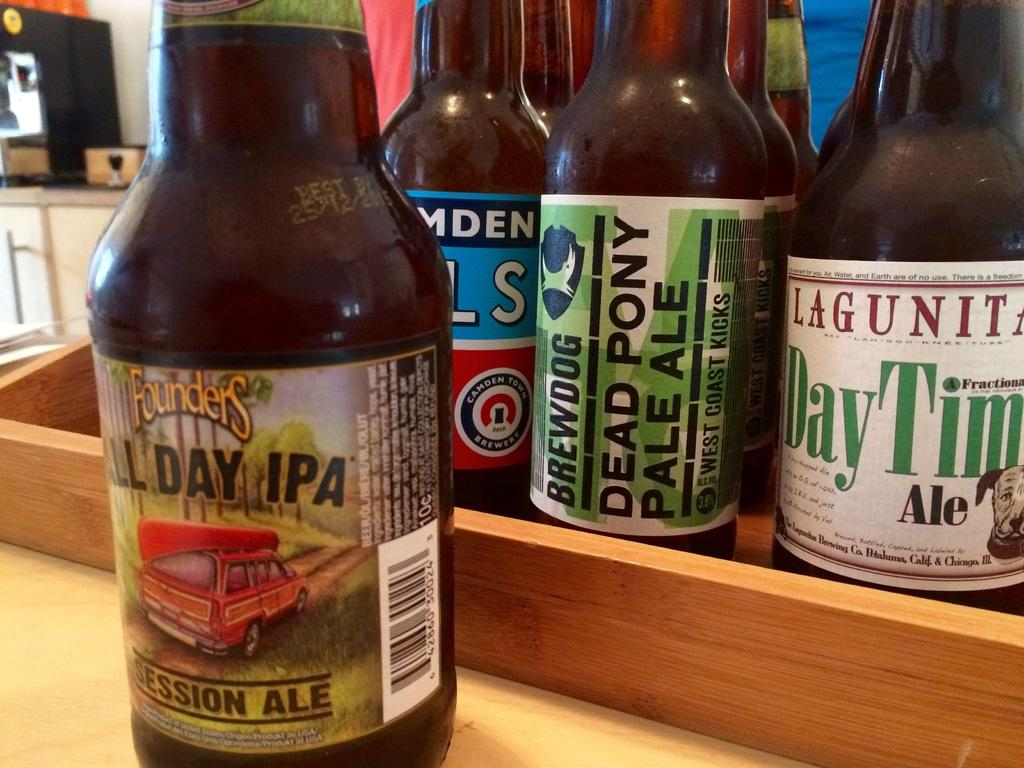Provide a one-sentence caption for the provided image. A bottle of Founders All Day IPA sits in front of a tray holding several more beer bottles. 